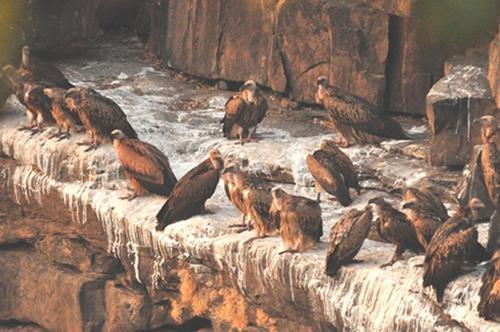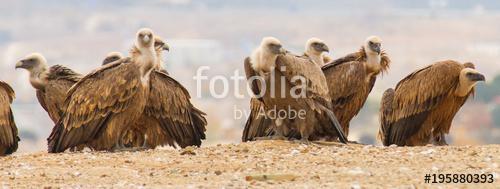The first image is the image on the left, the second image is the image on the right. Assess this claim about the two images: "In at least one image there is a single vulture on the ground with it wings expanded.". Correct or not? Answer yes or no. No. 